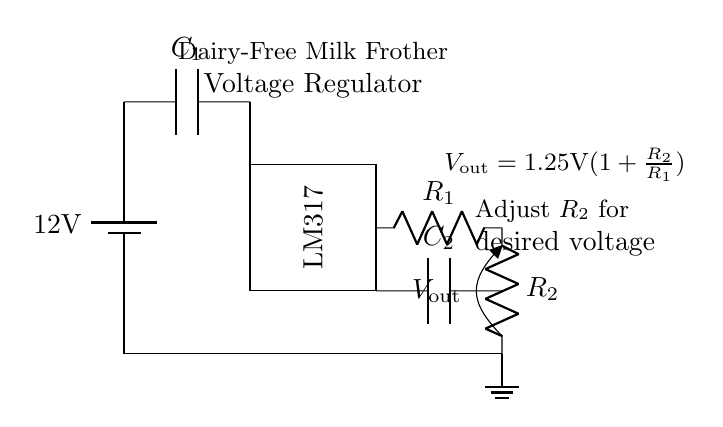What is the input voltage of the circuit? The input voltage is indicated on the battery and is noted as twelve volts.
Answer: twelve volts What component is used to regulate the voltage? The voltage regulator in this circuit is the LM317, which is labeled in the diagram.
Answer: LM317 What is the purpose of capacitor C1? Capacitor C1 is typically used to stabilize and filter the input voltage to the regulator, preventing fluctuations.
Answer: Stabilize input voltage What is the formula for the output voltage? The formula for the output voltage is given in the circuit: V out equals one point twenty-five volts multiplied by one plus the resistance ratio of R two to R one.
Answer: V out = 1.25V(1 + R2/R1) How can the output voltage be adjusted in this circuit? The output voltage can be adjusted by changing the value of resistor R2, as it affects the voltage output based on the formula.
Answer: By adjusting R2 What are the ground connections in the circuit? The ground connections are shown at the bottom of the circuit where all elements return to the common reference point, indicated by the symbol.
Answer: Common reference point What role does capacitor C2 play in this circuit? Capacitor C2 is used to filter and stabilize the output voltage, ensuring smooth operation of the load connected to the regulator.
Answer: Filter output voltage 